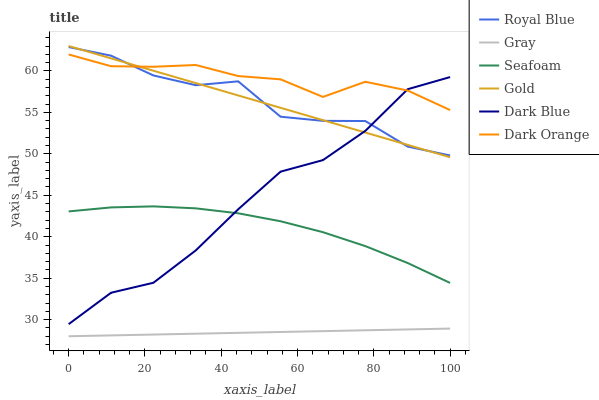Does Gray have the minimum area under the curve?
Answer yes or no. Yes. Does Dark Orange have the maximum area under the curve?
Answer yes or no. Yes. Does Gold have the minimum area under the curve?
Answer yes or no. No. Does Gold have the maximum area under the curve?
Answer yes or no. No. Is Gray the smoothest?
Answer yes or no. Yes. Is Royal Blue the roughest?
Answer yes or no. Yes. Is Gold the smoothest?
Answer yes or no. No. Is Gold the roughest?
Answer yes or no. No. Does Gray have the lowest value?
Answer yes or no. Yes. Does Gold have the lowest value?
Answer yes or no. No. Does Gold have the highest value?
Answer yes or no. Yes. Does Dark Blue have the highest value?
Answer yes or no. No. Is Gray less than Royal Blue?
Answer yes or no. Yes. Is Royal Blue greater than Gray?
Answer yes or no. Yes. Does Dark Orange intersect Dark Blue?
Answer yes or no. Yes. Is Dark Orange less than Dark Blue?
Answer yes or no. No. Is Dark Orange greater than Dark Blue?
Answer yes or no. No. Does Gray intersect Royal Blue?
Answer yes or no. No. 